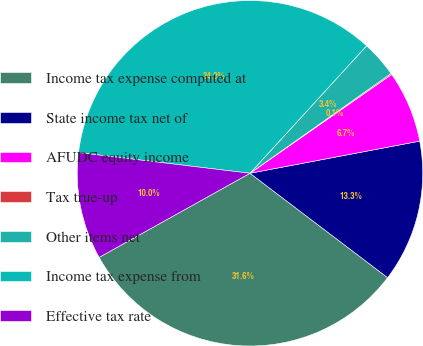<chart> <loc_0><loc_0><loc_500><loc_500><pie_chart><fcel>Income tax expense computed at<fcel>State income tax net of<fcel>AFUDC equity income<fcel>Tax true-up<fcel>Other items net<fcel>Income tax expense from<fcel>Effective tax rate<nl><fcel>31.58%<fcel>13.31%<fcel>6.71%<fcel>0.11%<fcel>3.41%<fcel>34.88%<fcel>10.01%<nl></chart> 